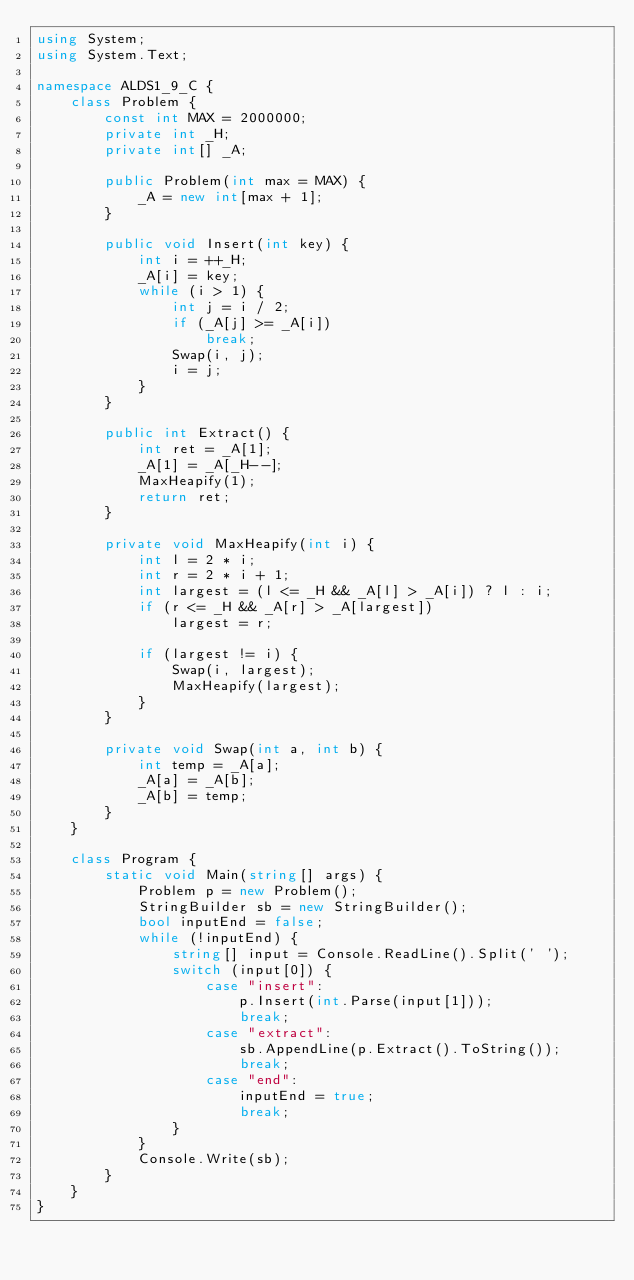<code> <loc_0><loc_0><loc_500><loc_500><_C#_>using System;
using System.Text;

namespace ALDS1_9_C {
    class Problem {
        const int MAX = 2000000;
        private int _H;
        private int[] _A;

        public Problem(int max = MAX) {
            _A = new int[max + 1];
        }

        public void Insert(int key) {
            int i = ++_H;
            _A[i] = key;
            while (i > 1) {
                int j = i / 2;
                if (_A[j] >= _A[i])
                    break;
                Swap(i, j);
                i = j;
            }
        }

        public int Extract() {
            int ret = _A[1];
            _A[1] = _A[_H--];
            MaxHeapify(1);
            return ret;
        }
        
        private void MaxHeapify(int i) {
            int l = 2 * i;
            int r = 2 * i + 1;
            int largest = (l <= _H && _A[l] > _A[i]) ? l : i;
            if (r <= _H && _A[r] > _A[largest])
                largest = r;

            if (largest != i) {
                Swap(i, largest);
                MaxHeapify(largest);
            }
        }

        private void Swap(int a, int b) {
            int temp = _A[a];
            _A[a] = _A[b];
            _A[b] = temp;
        }
    }

    class Program {
        static void Main(string[] args) {
            Problem p = new Problem();
            StringBuilder sb = new StringBuilder();
            bool inputEnd = false;
            while (!inputEnd) {
                string[] input = Console.ReadLine().Split(' ');
                switch (input[0]) {
                    case "insert":
                        p.Insert(int.Parse(input[1]));
                        break;
                    case "extract":
                        sb.AppendLine(p.Extract().ToString());
                        break;
                    case "end":
                        inputEnd = true;
                        break;
                }
            }
            Console.Write(sb);
        }
    }
}</code> 